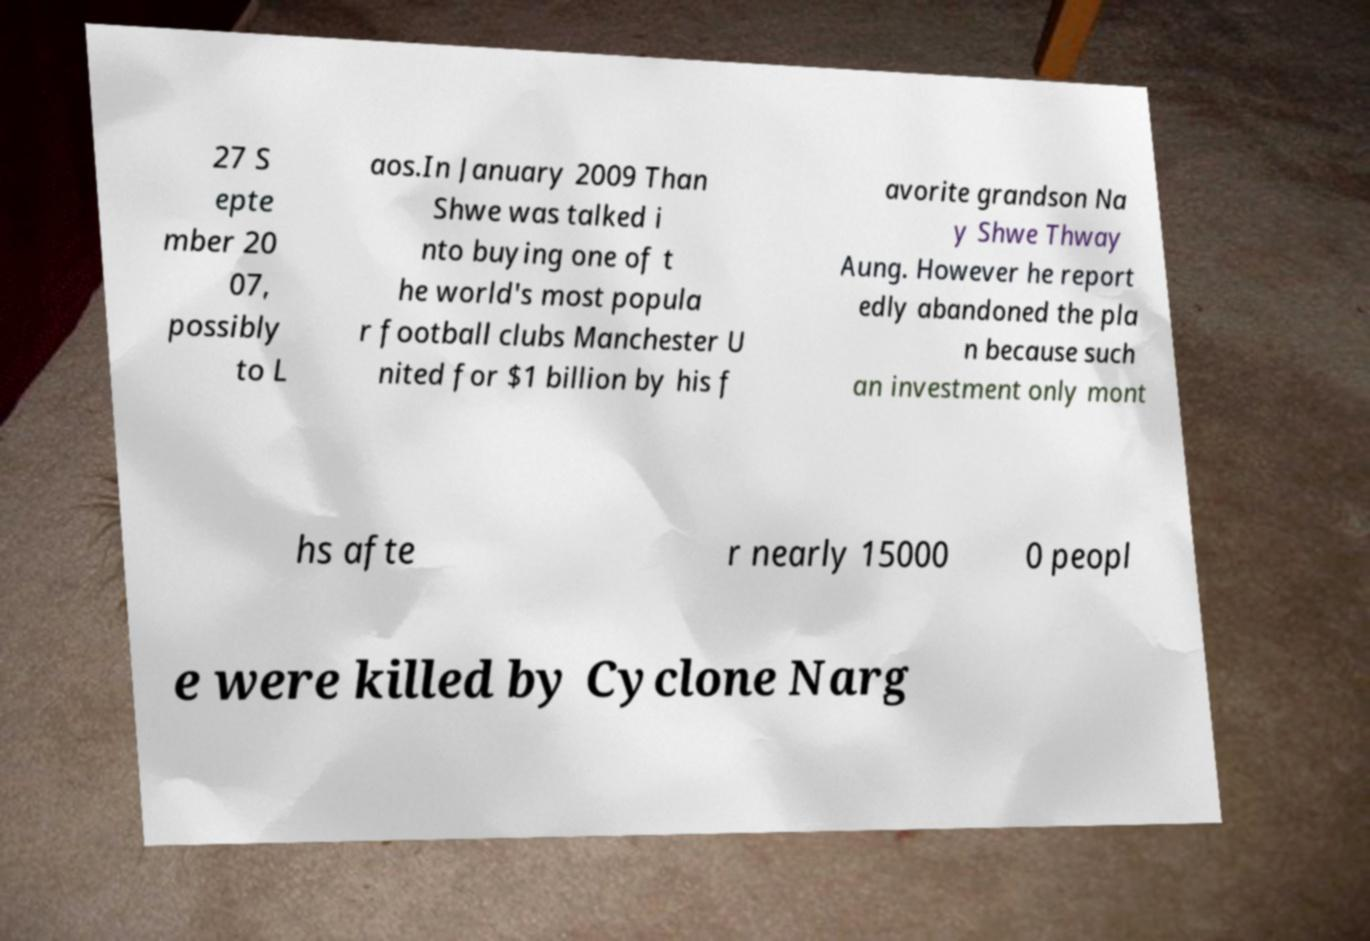Could you assist in decoding the text presented in this image and type it out clearly? 27 S epte mber 20 07, possibly to L aos.In January 2009 Than Shwe was talked i nto buying one of t he world's most popula r football clubs Manchester U nited for $1 billion by his f avorite grandson Na y Shwe Thway Aung. However he report edly abandoned the pla n because such an investment only mont hs afte r nearly 15000 0 peopl e were killed by Cyclone Narg 